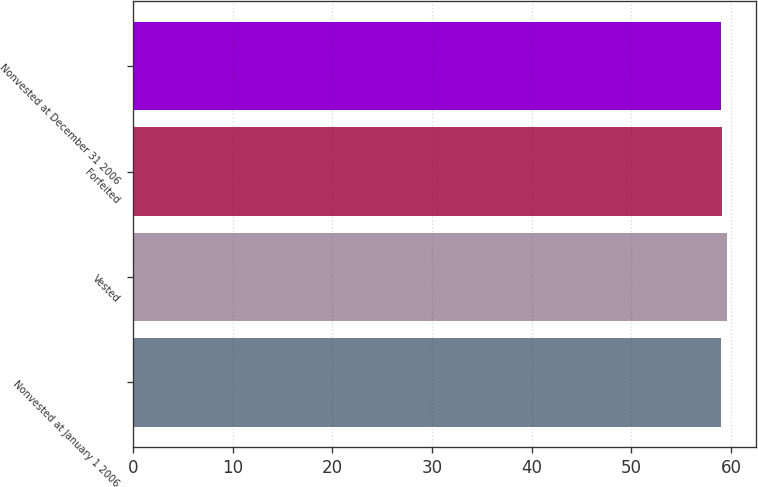<chart> <loc_0><loc_0><loc_500><loc_500><bar_chart><fcel>Nonvested at January 1 2006<fcel>Vested<fcel>Forfeited<fcel>Nonvested at December 31 2006<nl><fcel>58.95<fcel>59.57<fcel>59.07<fcel>59.01<nl></chart> 